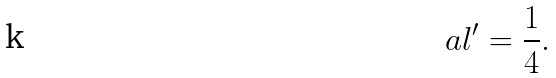<formula> <loc_0><loc_0><loc_500><loc_500>\ a l ^ { \prime } = \frac { 1 } { 4 } .</formula> 